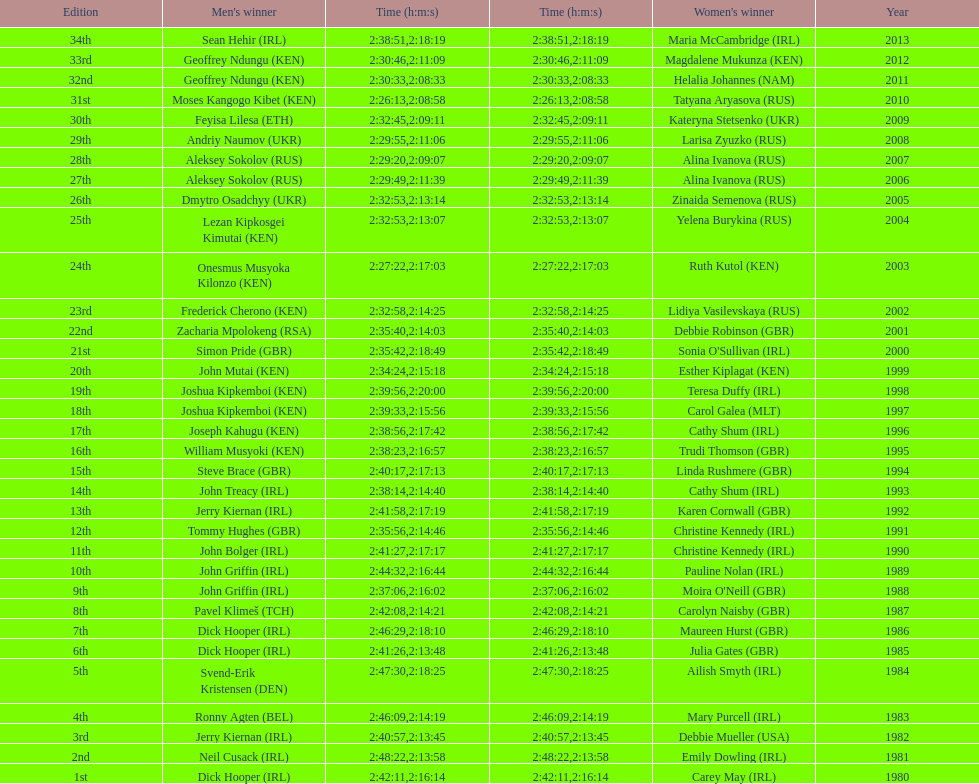Who had the most amount of time out of all the runners? Maria McCambridge (IRL). 